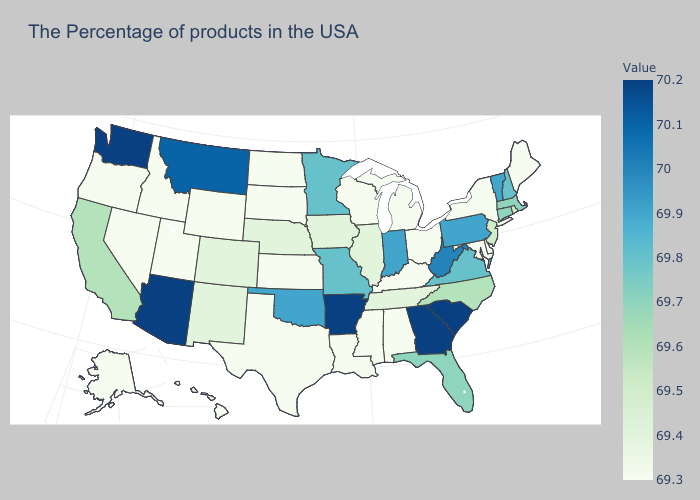Does the map have missing data?
Short answer required. No. Among the states that border North Dakota , which have the lowest value?
Concise answer only. South Dakota. Does Arizona have the highest value in the West?
Quick response, please. Yes. Among the states that border Kentucky , does Ohio have the lowest value?
Write a very short answer. Yes. Does the map have missing data?
Write a very short answer. No. Does Alabama have the highest value in the South?
Quick response, please. No. 